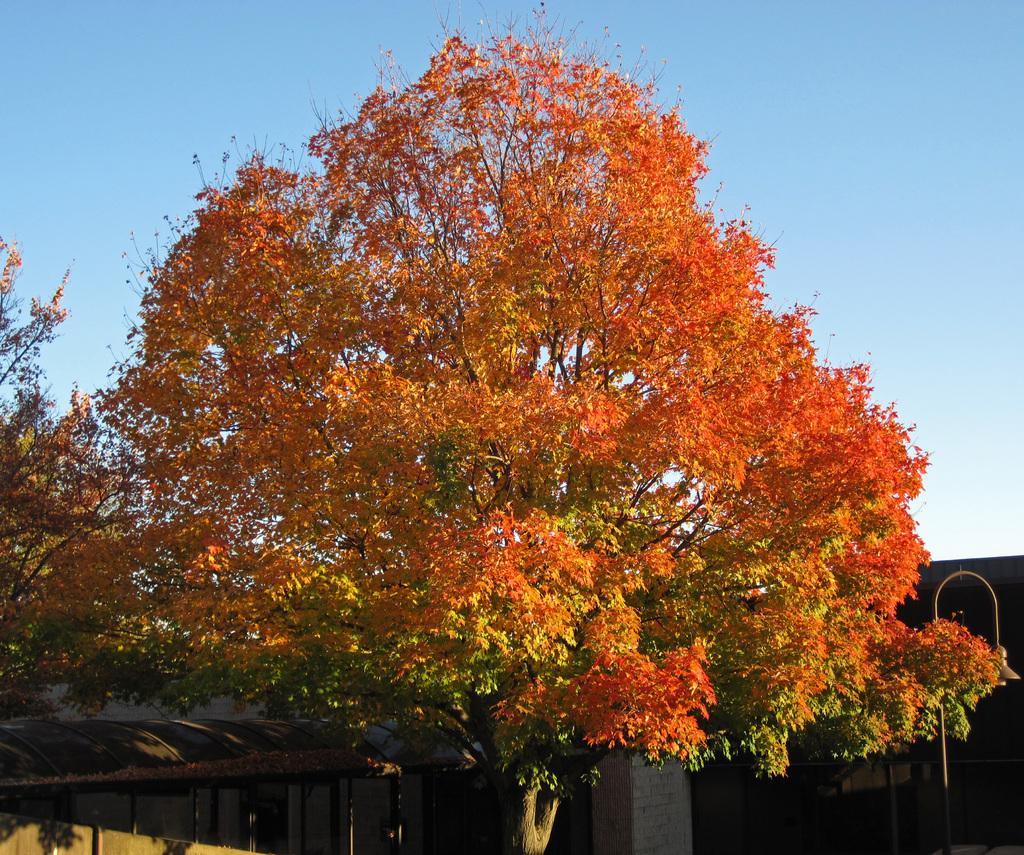Please provide a concise description of this image. In the center of the image we can see one tree,which is in yellow,orange and green color. In the background we can see the sky,one building,pillar,shed,poles and a few other objects. 